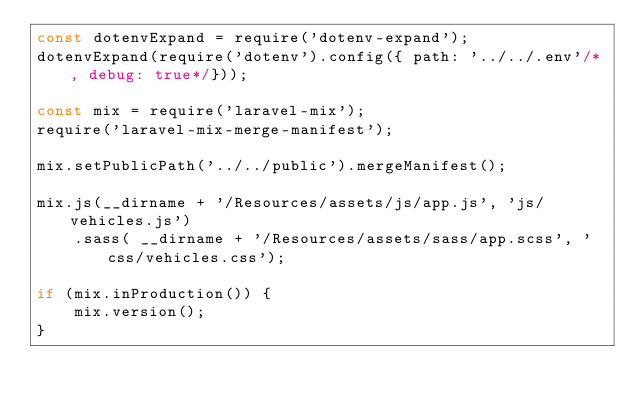<code> <loc_0><loc_0><loc_500><loc_500><_JavaScript_>const dotenvExpand = require('dotenv-expand');
dotenvExpand(require('dotenv').config({ path: '../../.env'/*, debug: true*/}));

const mix = require('laravel-mix');
require('laravel-mix-merge-manifest');

mix.setPublicPath('../../public').mergeManifest();

mix.js(__dirname + '/Resources/assets/js/app.js', 'js/vehicles.js')
    .sass( __dirname + '/Resources/assets/sass/app.scss', 'css/vehicles.css');

if (mix.inProduction()) {
    mix.version();
}
</code> 